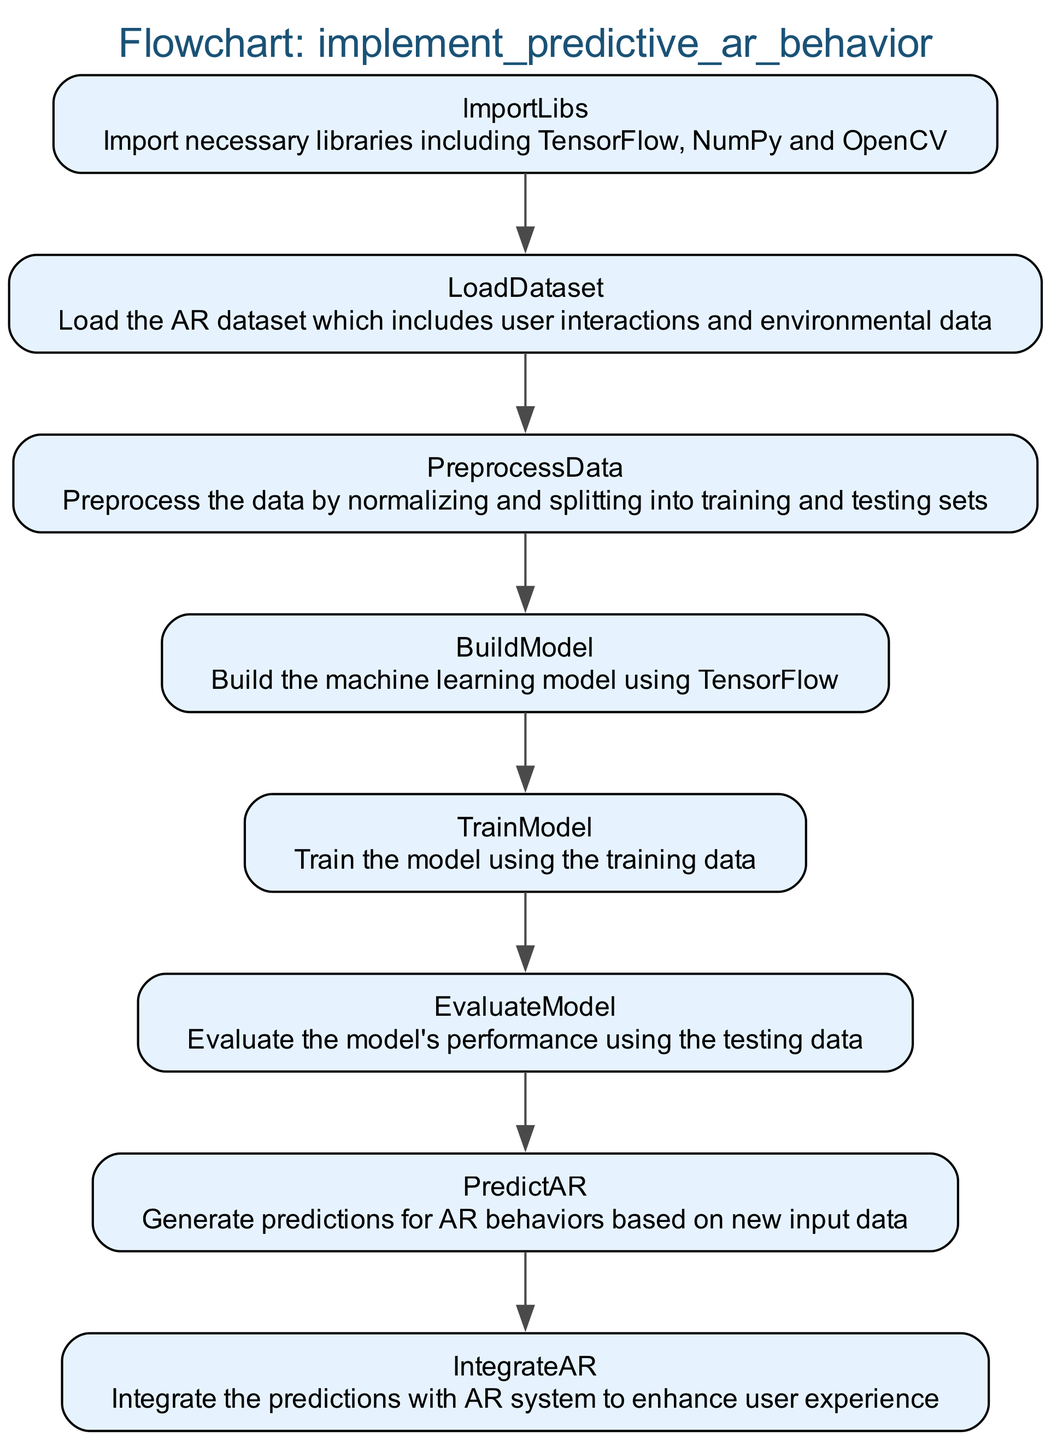What is the first step in the flowchart? The flowchart starts with "ImportLibs," which indicates the initial action is to import necessary libraries.
Answer: ImportLibs How many nodes are there in the diagram? The diagram lists eight distinct steps, each represented as a node in the flowchart.
Answer: 8 Which step comes immediately after "PreprocessData"? The step that follows "PreprocessData" is "BuildModel," indicating the sequence of operations in the flowchart.
Answer: BuildModel What is the last step in the flowchart? The final action in the flowchart is "IntegrateAR," marking the conclusion of the process flow.
Answer: IntegrateAR What library is imported in the first step? The first step includes the importation of TensorFlow, which is crucial for building the machine learning model.
Answer: TensorFlow In which step is the model trained? The model is trained in the "TrainModel" step, where the fitting of the model occurs using the training dataset.
Answer: TrainModel How is the model evaluated according to the flowchart? The model is evaluated in the "EvaluateModel" step, using testing data to assess its performance.
Answer: EvaluateModel What does the "PredictAR" step generate? The "PredictAR" step generates predictions related to augmented reality behaviors based on new input data.
Answer: Predictions 